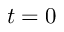<formula> <loc_0><loc_0><loc_500><loc_500>t = 0</formula> 